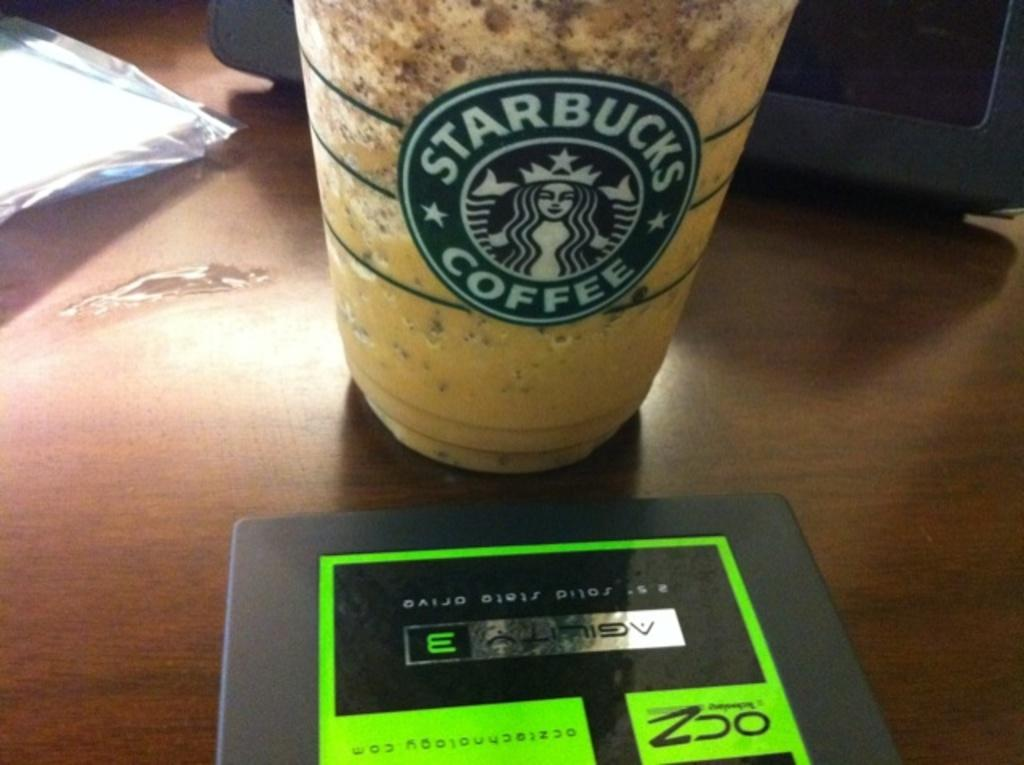What is the main object visible in the image? There is a cup in the image. What is written on the cup? The cup has the name "Starbucks Coffee" on it. What else can be seen on the table in the image? There are other objects on the table in the image. What type of fiction is being read by the cup in the image? There is no person or book present in the image, so it is not possible to determine if any fiction is being read. 